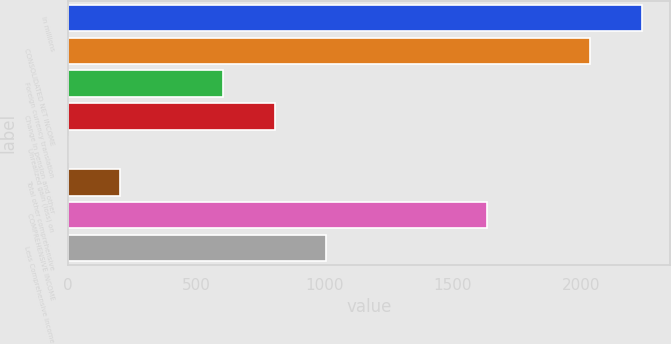Convert chart. <chart><loc_0><loc_0><loc_500><loc_500><bar_chart><fcel>In millions<fcel>CONSOLIDATED NET INCOME<fcel>Foreign currency translation<fcel>Change in pension and other<fcel>Unrealized gain (loss) on<fcel>Total other comprehensive<fcel>COMPREHENSIVE INCOME<fcel>Less Comprehensive income<nl><fcel>2236<fcel>2035<fcel>605<fcel>806<fcel>2<fcel>203<fcel>1633<fcel>1007<nl></chart> 